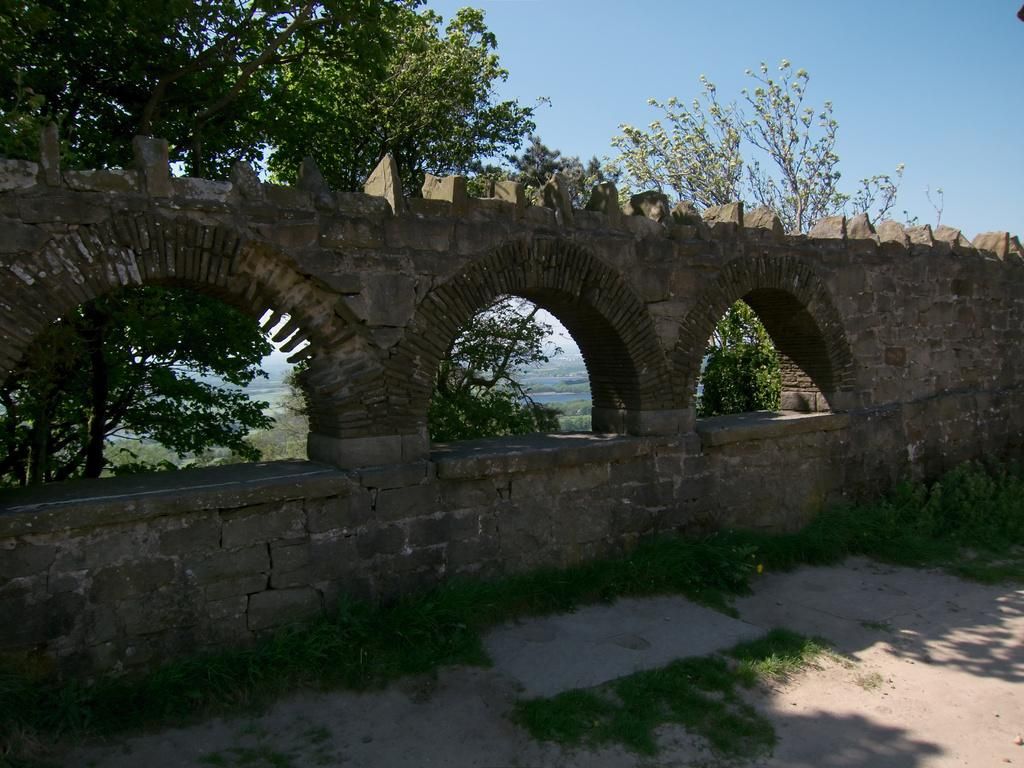What type of structure can be seen in the image? There is a wall in the image. What natural elements are present in the image? There are trees, water, and grass visible in the image. What part of the natural environment is visible in the image? The sky is visible in the background of the image. How many pizzas can be seen on the wall in the image? There are no pizzas present in the image; it features a wall, trees, water, grass, and the sky. What type of kettle is visible in the image? There is no kettle present in the image. 